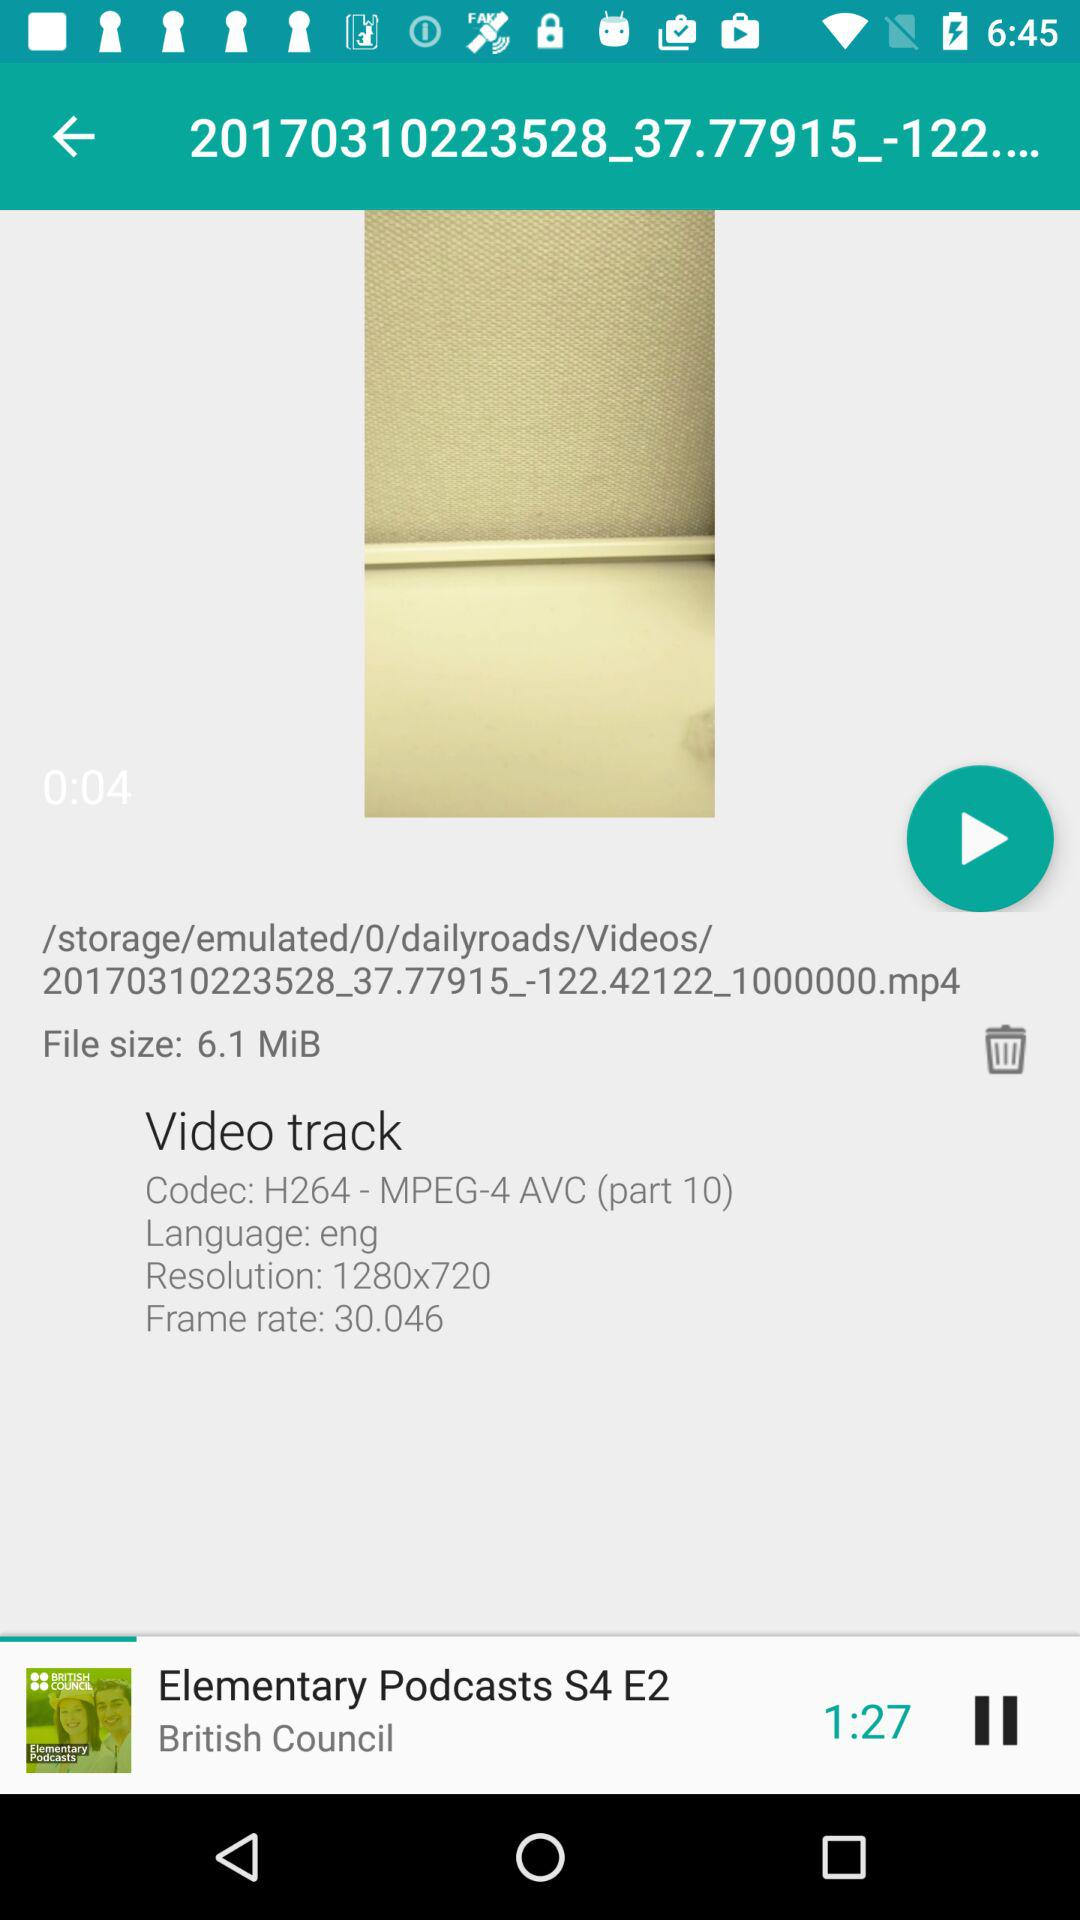What is the resolution of the video?
Answer the question using a single word or phrase. 1280x720 